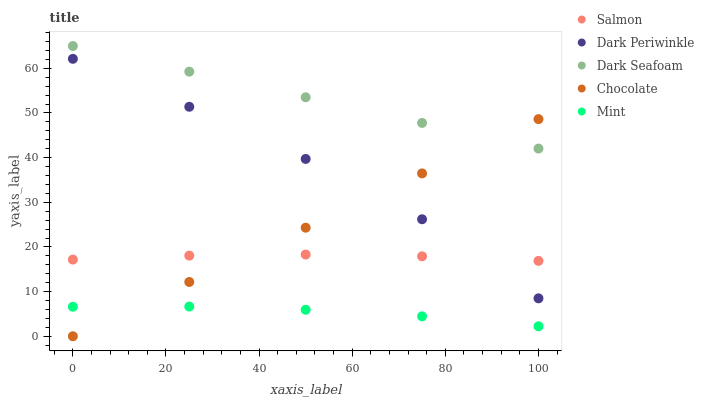Does Mint have the minimum area under the curve?
Answer yes or no. Yes. Does Dark Seafoam have the maximum area under the curve?
Answer yes or no. Yes. Does Salmon have the minimum area under the curve?
Answer yes or no. No. Does Salmon have the maximum area under the curve?
Answer yes or no. No. Is Chocolate the smoothest?
Answer yes or no. Yes. Is Dark Periwinkle the roughest?
Answer yes or no. Yes. Is Dark Seafoam the smoothest?
Answer yes or no. No. Is Dark Seafoam the roughest?
Answer yes or no. No. Does Chocolate have the lowest value?
Answer yes or no. Yes. Does Salmon have the lowest value?
Answer yes or no. No. Does Dark Seafoam have the highest value?
Answer yes or no. Yes. Does Salmon have the highest value?
Answer yes or no. No. Is Mint less than Dark Periwinkle?
Answer yes or no. Yes. Is Dark Seafoam greater than Dark Periwinkle?
Answer yes or no. Yes. Does Chocolate intersect Salmon?
Answer yes or no. Yes. Is Chocolate less than Salmon?
Answer yes or no. No. Is Chocolate greater than Salmon?
Answer yes or no. No. Does Mint intersect Dark Periwinkle?
Answer yes or no. No. 